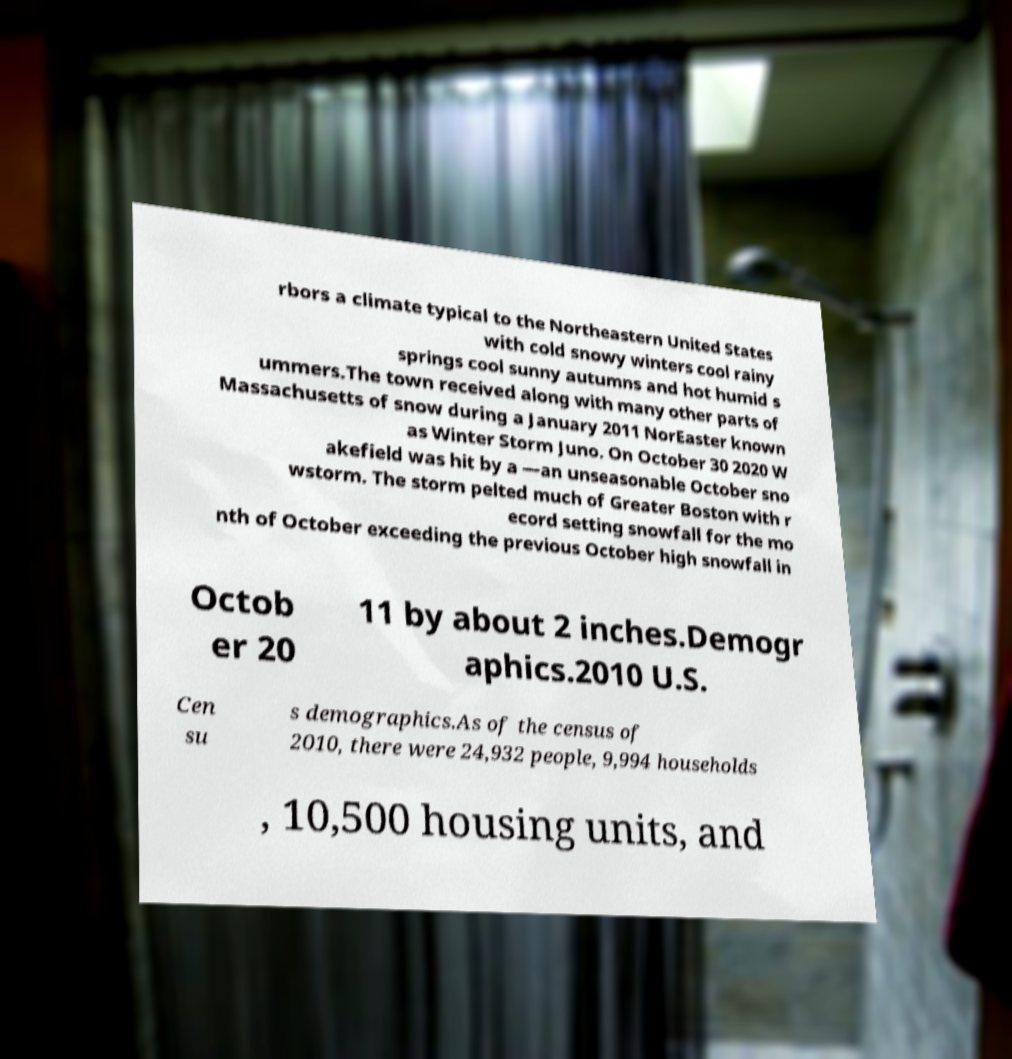Can you read and provide the text displayed in the image?This photo seems to have some interesting text. Can you extract and type it out for me? rbors a climate typical to the Northeastern United States with cold snowy winters cool rainy springs cool sunny autumns and hot humid s ummers.The town received along with many other parts of Massachusetts of snow during a January 2011 NorEaster known as Winter Storm Juno. On October 30 2020 W akefield was hit by a —an unseasonable October sno wstorm. The storm pelted much of Greater Boston with r ecord setting snowfall for the mo nth of October exceeding the previous October high snowfall in Octob er 20 11 by about 2 inches.Demogr aphics.2010 U.S. Cen su s demographics.As of the census of 2010, there were 24,932 people, 9,994 households , 10,500 housing units, and 